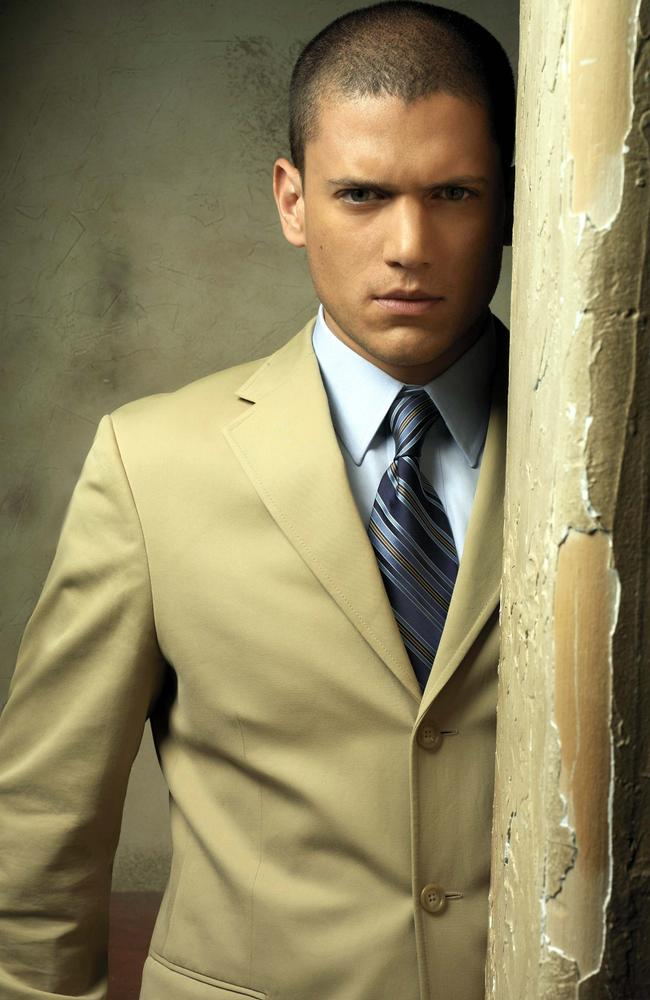Can you provide a more casual description of what's happening in this image? Here, we see a person dressed sharply in a beige suit and a blue striped tie, leaning against an old wall with peeling paint. Their direct gaze at the camera adds a sense of seriousness to the otherwise relaxed pose. 